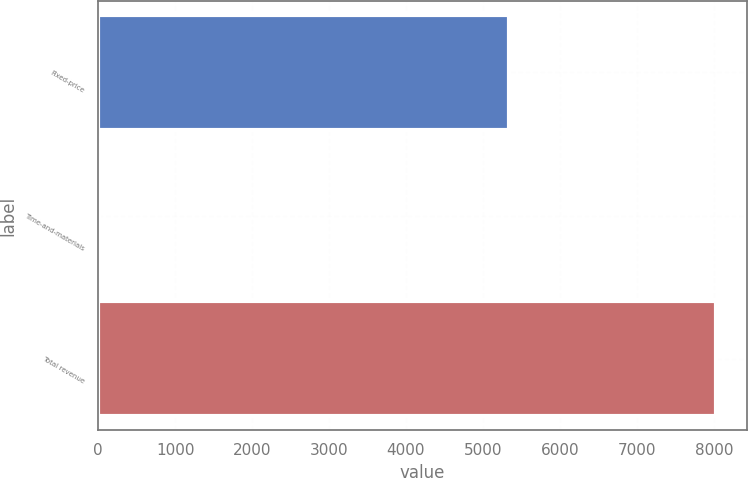<chart> <loc_0><loc_0><loc_500><loc_500><bar_chart><fcel>Fixed-price<fcel>Time-and-materials<fcel>Total revenue<nl><fcel>5334<fcel>13<fcel>8032<nl></chart> 